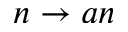<formula> <loc_0><loc_0><loc_500><loc_500>n \rightarrow a n</formula> 